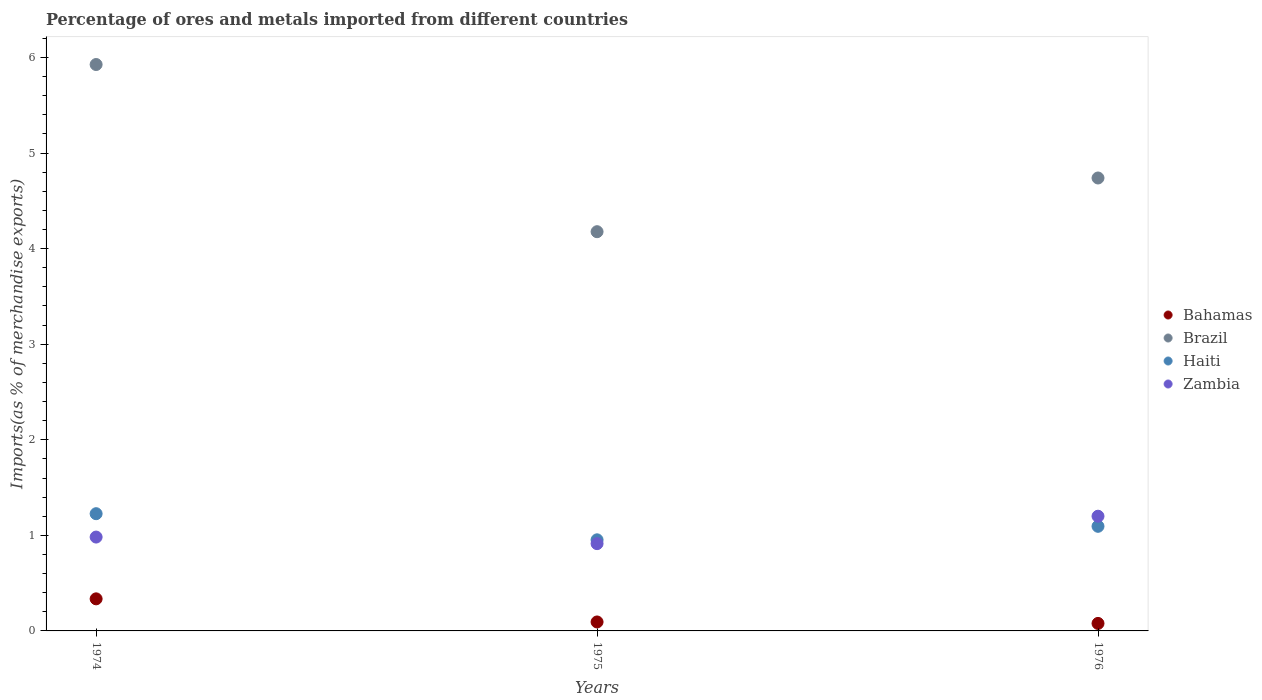Is the number of dotlines equal to the number of legend labels?
Your answer should be compact. Yes. What is the percentage of imports to different countries in Zambia in 1975?
Your answer should be very brief. 0.91. Across all years, what is the maximum percentage of imports to different countries in Haiti?
Make the answer very short. 1.23. Across all years, what is the minimum percentage of imports to different countries in Zambia?
Offer a very short reply. 0.91. In which year was the percentage of imports to different countries in Brazil maximum?
Your response must be concise. 1974. In which year was the percentage of imports to different countries in Bahamas minimum?
Your response must be concise. 1976. What is the total percentage of imports to different countries in Haiti in the graph?
Offer a terse response. 3.27. What is the difference between the percentage of imports to different countries in Haiti in 1974 and that in 1976?
Give a very brief answer. 0.13. What is the difference between the percentage of imports to different countries in Zambia in 1976 and the percentage of imports to different countries in Haiti in 1974?
Your answer should be very brief. -0.03. What is the average percentage of imports to different countries in Zambia per year?
Offer a terse response. 1.03. In the year 1974, what is the difference between the percentage of imports to different countries in Brazil and percentage of imports to different countries in Haiti?
Your answer should be compact. 4.7. What is the ratio of the percentage of imports to different countries in Bahamas in 1974 to that in 1975?
Provide a succinct answer. 3.58. Is the percentage of imports to different countries in Haiti in 1974 less than that in 1975?
Give a very brief answer. No. What is the difference between the highest and the second highest percentage of imports to different countries in Zambia?
Offer a terse response. 0.22. What is the difference between the highest and the lowest percentage of imports to different countries in Brazil?
Your answer should be compact. 1.75. Is the sum of the percentage of imports to different countries in Zambia in 1974 and 1976 greater than the maximum percentage of imports to different countries in Bahamas across all years?
Your response must be concise. Yes. Is the percentage of imports to different countries in Zambia strictly less than the percentage of imports to different countries in Bahamas over the years?
Provide a succinct answer. No. How many dotlines are there?
Your answer should be compact. 4. How many years are there in the graph?
Provide a succinct answer. 3. Are the values on the major ticks of Y-axis written in scientific E-notation?
Your response must be concise. No. Does the graph contain any zero values?
Provide a short and direct response. No. What is the title of the graph?
Make the answer very short. Percentage of ores and metals imported from different countries. What is the label or title of the X-axis?
Your answer should be very brief. Years. What is the label or title of the Y-axis?
Your answer should be very brief. Imports(as % of merchandise exports). What is the Imports(as % of merchandise exports) in Bahamas in 1974?
Offer a terse response. 0.34. What is the Imports(as % of merchandise exports) in Brazil in 1974?
Offer a terse response. 5.93. What is the Imports(as % of merchandise exports) of Haiti in 1974?
Make the answer very short. 1.23. What is the Imports(as % of merchandise exports) of Zambia in 1974?
Provide a short and direct response. 0.98. What is the Imports(as % of merchandise exports) in Bahamas in 1975?
Your response must be concise. 0.09. What is the Imports(as % of merchandise exports) in Brazil in 1975?
Offer a terse response. 4.18. What is the Imports(as % of merchandise exports) of Haiti in 1975?
Ensure brevity in your answer.  0.95. What is the Imports(as % of merchandise exports) of Zambia in 1975?
Your response must be concise. 0.91. What is the Imports(as % of merchandise exports) of Bahamas in 1976?
Ensure brevity in your answer.  0.08. What is the Imports(as % of merchandise exports) in Brazil in 1976?
Your answer should be very brief. 4.74. What is the Imports(as % of merchandise exports) of Haiti in 1976?
Offer a terse response. 1.09. What is the Imports(as % of merchandise exports) in Zambia in 1976?
Your answer should be very brief. 1.2. Across all years, what is the maximum Imports(as % of merchandise exports) in Bahamas?
Provide a succinct answer. 0.34. Across all years, what is the maximum Imports(as % of merchandise exports) in Brazil?
Offer a very short reply. 5.93. Across all years, what is the maximum Imports(as % of merchandise exports) in Haiti?
Provide a succinct answer. 1.23. Across all years, what is the maximum Imports(as % of merchandise exports) of Zambia?
Keep it short and to the point. 1.2. Across all years, what is the minimum Imports(as % of merchandise exports) of Bahamas?
Your response must be concise. 0.08. Across all years, what is the minimum Imports(as % of merchandise exports) of Brazil?
Give a very brief answer. 4.18. Across all years, what is the minimum Imports(as % of merchandise exports) of Haiti?
Offer a very short reply. 0.95. Across all years, what is the minimum Imports(as % of merchandise exports) of Zambia?
Keep it short and to the point. 0.91. What is the total Imports(as % of merchandise exports) of Bahamas in the graph?
Your answer should be compact. 0.51. What is the total Imports(as % of merchandise exports) of Brazil in the graph?
Offer a very short reply. 14.84. What is the total Imports(as % of merchandise exports) of Haiti in the graph?
Offer a very short reply. 3.27. What is the total Imports(as % of merchandise exports) in Zambia in the graph?
Provide a short and direct response. 3.1. What is the difference between the Imports(as % of merchandise exports) in Bahamas in 1974 and that in 1975?
Offer a terse response. 0.24. What is the difference between the Imports(as % of merchandise exports) in Brazil in 1974 and that in 1975?
Offer a terse response. 1.75. What is the difference between the Imports(as % of merchandise exports) of Haiti in 1974 and that in 1975?
Offer a terse response. 0.27. What is the difference between the Imports(as % of merchandise exports) in Zambia in 1974 and that in 1975?
Ensure brevity in your answer.  0.07. What is the difference between the Imports(as % of merchandise exports) in Bahamas in 1974 and that in 1976?
Make the answer very short. 0.26. What is the difference between the Imports(as % of merchandise exports) in Brazil in 1974 and that in 1976?
Keep it short and to the point. 1.19. What is the difference between the Imports(as % of merchandise exports) in Haiti in 1974 and that in 1976?
Provide a short and direct response. 0.13. What is the difference between the Imports(as % of merchandise exports) in Zambia in 1974 and that in 1976?
Give a very brief answer. -0.22. What is the difference between the Imports(as % of merchandise exports) in Bahamas in 1975 and that in 1976?
Offer a terse response. 0.02. What is the difference between the Imports(as % of merchandise exports) in Brazil in 1975 and that in 1976?
Give a very brief answer. -0.56. What is the difference between the Imports(as % of merchandise exports) in Haiti in 1975 and that in 1976?
Your answer should be very brief. -0.14. What is the difference between the Imports(as % of merchandise exports) in Zambia in 1975 and that in 1976?
Ensure brevity in your answer.  -0.29. What is the difference between the Imports(as % of merchandise exports) of Bahamas in 1974 and the Imports(as % of merchandise exports) of Brazil in 1975?
Ensure brevity in your answer.  -3.84. What is the difference between the Imports(as % of merchandise exports) in Bahamas in 1974 and the Imports(as % of merchandise exports) in Haiti in 1975?
Keep it short and to the point. -0.62. What is the difference between the Imports(as % of merchandise exports) of Bahamas in 1974 and the Imports(as % of merchandise exports) of Zambia in 1975?
Keep it short and to the point. -0.58. What is the difference between the Imports(as % of merchandise exports) in Brazil in 1974 and the Imports(as % of merchandise exports) in Haiti in 1975?
Offer a terse response. 4.97. What is the difference between the Imports(as % of merchandise exports) in Brazil in 1974 and the Imports(as % of merchandise exports) in Zambia in 1975?
Your response must be concise. 5.01. What is the difference between the Imports(as % of merchandise exports) in Haiti in 1974 and the Imports(as % of merchandise exports) in Zambia in 1975?
Provide a short and direct response. 0.31. What is the difference between the Imports(as % of merchandise exports) in Bahamas in 1974 and the Imports(as % of merchandise exports) in Brazil in 1976?
Your answer should be compact. -4.4. What is the difference between the Imports(as % of merchandise exports) in Bahamas in 1974 and the Imports(as % of merchandise exports) in Haiti in 1976?
Your response must be concise. -0.76. What is the difference between the Imports(as % of merchandise exports) of Bahamas in 1974 and the Imports(as % of merchandise exports) of Zambia in 1976?
Give a very brief answer. -0.86. What is the difference between the Imports(as % of merchandise exports) of Brazil in 1974 and the Imports(as % of merchandise exports) of Haiti in 1976?
Offer a terse response. 4.83. What is the difference between the Imports(as % of merchandise exports) in Brazil in 1974 and the Imports(as % of merchandise exports) in Zambia in 1976?
Your answer should be compact. 4.73. What is the difference between the Imports(as % of merchandise exports) of Haiti in 1974 and the Imports(as % of merchandise exports) of Zambia in 1976?
Your answer should be very brief. 0.03. What is the difference between the Imports(as % of merchandise exports) of Bahamas in 1975 and the Imports(as % of merchandise exports) of Brazil in 1976?
Your answer should be very brief. -4.65. What is the difference between the Imports(as % of merchandise exports) of Bahamas in 1975 and the Imports(as % of merchandise exports) of Haiti in 1976?
Ensure brevity in your answer.  -1. What is the difference between the Imports(as % of merchandise exports) of Bahamas in 1975 and the Imports(as % of merchandise exports) of Zambia in 1976?
Your response must be concise. -1.11. What is the difference between the Imports(as % of merchandise exports) of Brazil in 1975 and the Imports(as % of merchandise exports) of Haiti in 1976?
Provide a succinct answer. 3.08. What is the difference between the Imports(as % of merchandise exports) of Brazil in 1975 and the Imports(as % of merchandise exports) of Zambia in 1976?
Give a very brief answer. 2.98. What is the difference between the Imports(as % of merchandise exports) of Haiti in 1975 and the Imports(as % of merchandise exports) of Zambia in 1976?
Ensure brevity in your answer.  -0.25. What is the average Imports(as % of merchandise exports) in Bahamas per year?
Your answer should be very brief. 0.17. What is the average Imports(as % of merchandise exports) of Brazil per year?
Ensure brevity in your answer.  4.95. What is the average Imports(as % of merchandise exports) in Haiti per year?
Offer a terse response. 1.09. What is the average Imports(as % of merchandise exports) of Zambia per year?
Ensure brevity in your answer.  1.03. In the year 1974, what is the difference between the Imports(as % of merchandise exports) in Bahamas and Imports(as % of merchandise exports) in Brazil?
Your answer should be very brief. -5.59. In the year 1974, what is the difference between the Imports(as % of merchandise exports) in Bahamas and Imports(as % of merchandise exports) in Haiti?
Give a very brief answer. -0.89. In the year 1974, what is the difference between the Imports(as % of merchandise exports) in Bahamas and Imports(as % of merchandise exports) in Zambia?
Offer a terse response. -0.65. In the year 1974, what is the difference between the Imports(as % of merchandise exports) in Brazil and Imports(as % of merchandise exports) in Haiti?
Provide a succinct answer. 4.7. In the year 1974, what is the difference between the Imports(as % of merchandise exports) in Brazil and Imports(as % of merchandise exports) in Zambia?
Your response must be concise. 4.94. In the year 1974, what is the difference between the Imports(as % of merchandise exports) in Haiti and Imports(as % of merchandise exports) in Zambia?
Offer a very short reply. 0.24. In the year 1975, what is the difference between the Imports(as % of merchandise exports) of Bahamas and Imports(as % of merchandise exports) of Brazil?
Give a very brief answer. -4.08. In the year 1975, what is the difference between the Imports(as % of merchandise exports) in Bahamas and Imports(as % of merchandise exports) in Haiti?
Keep it short and to the point. -0.86. In the year 1975, what is the difference between the Imports(as % of merchandise exports) of Bahamas and Imports(as % of merchandise exports) of Zambia?
Your response must be concise. -0.82. In the year 1975, what is the difference between the Imports(as % of merchandise exports) in Brazil and Imports(as % of merchandise exports) in Haiti?
Give a very brief answer. 3.22. In the year 1975, what is the difference between the Imports(as % of merchandise exports) of Brazil and Imports(as % of merchandise exports) of Zambia?
Provide a succinct answer. 3.26. In the year 1976, what is the difference between the Imports(as % of merchandise exports) in Bahamas and Imports(as % of merchandise exports) in Brazil?
Make the answer very short. -4.66. In the year 1976, what is the difference between the Imports(as % of merchandise exports) in Bahamas and Imports(as % of merchandise exports) in Haiti?
Provide a succinct answer. -1.02. In the year 1976, what is the difference between the Imports(as % of merchandise exports) of Bahamas and Imports(as % of merchandise exports) of Zambia?
Provide a short and direct response. -1.12. In the year 1976, what is the difference between the Imports(as % of merchandise exports) in Brazil and Imports(as % of merchandise exports) in Haiti?
Ensure brevity in your answer.  3.64. In the year 1976, what is the difference between the Imports(as % of merchandise exports) in Brazil and Imports(as % of merchandise exports) in Zambia?
Give a very brief answer. 3.54. In the year 1976, what is the difference between the Imports(as % of merchandise exports) in Haiti and Imports(as % of merchandise exports) in Zambia?
Your response must be concise. -0.11. What is the ratio of the Imports(as % of merchandise exports) of Bahamas in 1974 to that in 1975?
Your response must be concise. 3.58. What is the ratio of the Imports(as % of merchandise exports) in Brazil in 1974 to that in 1975?
Give a very brief answer. 1.42. What is the ratio of the Imports(as % of merchandise exports) in Haiti in 1974 to that in 1975?
Offer a terse response. 1.29. What is the ratio of the Imports(as % of merchandise exports) in Zambia in 1974 to that in 1975?
Your response must be concise. 1.08. What is the ratio of the Imports(as % of merchandise exports) of Bahamas in 1974 to that in 1976?
Make the answer very short. 4.28. What is the ratio of the Imports(as % of merchandise exports) in Brazil in 1974 to that in 1976?
Keep it short and to the point. 1.25. What is the ratio of the Imports(as % of merchandise exports) of Haiti in 1974 to that in 1976?
Your response must be concise. 1.12. What is the ratio of the Imports(as % of merchandise exports) in Zambia in 1974 to that in 1976?
Make the answer very short. 0.82. What is the ratio of the Imports(as % of merchandise exports) in Bahamas in 1975 to that in 1976?
Make the answer very short. 1.2. What is the ratio of the Imports(as % of merchandise exports) in Brazil in 1975 to that in 1976?
Provide a short and direct response. 0.88. What is the ratio of the Imports(as % of merchandise exports) of Haiti in 1975 to that in 1976?
Your answer should be very brief. 0.87. What is the ratio of the Imports(as % of merchandise exports) of Zambia in 1975 to that in 1976?
Offer a terse response. 0.76. What is the difference between the highest and the second highest Imports(as % of merchandise exports) in Bahamas?
Your answer should be compact. 0.24. What is the difference between the highest and the second highest Imports(as % of merchandise exports) in Brazil?
Your response must be concise. 1.19. What is the difference between the highest and the second highest Imports(as % of merchandise exports) in Haiti?
Ensure brevity in your answer.  0.13. What is the difference between the highest and the second highest Imports(as % of merchandise exports) in Zambia?
Offer a very short reply. 0.22. What is the difference between the highest and the lowest Imports(as % of merchandise exports) of Bahamas?
Offer a very short reply. 0.26. What is the difference between the highest and the lowest Imports(as % of merchandise exports) of Brazil?
Keep it short and to the point. 1.75. What is the difference between the highest and the lowest Imports(as % of merchandise exports) in Haiti?
Provide a succinct answer. 0.27. What is the difference between the highest and the lowest Imports(as % of merchandise exports) of Zambia?
Your response must be concise. 0.29. 